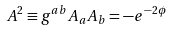<formula> <loc_0><loc_0><loc_500><loc_500>A ^ { 2 } \equiv g ^ { a b } A _ { a } A _ { b } = - e ^ { - 2 \phi }</formula> 